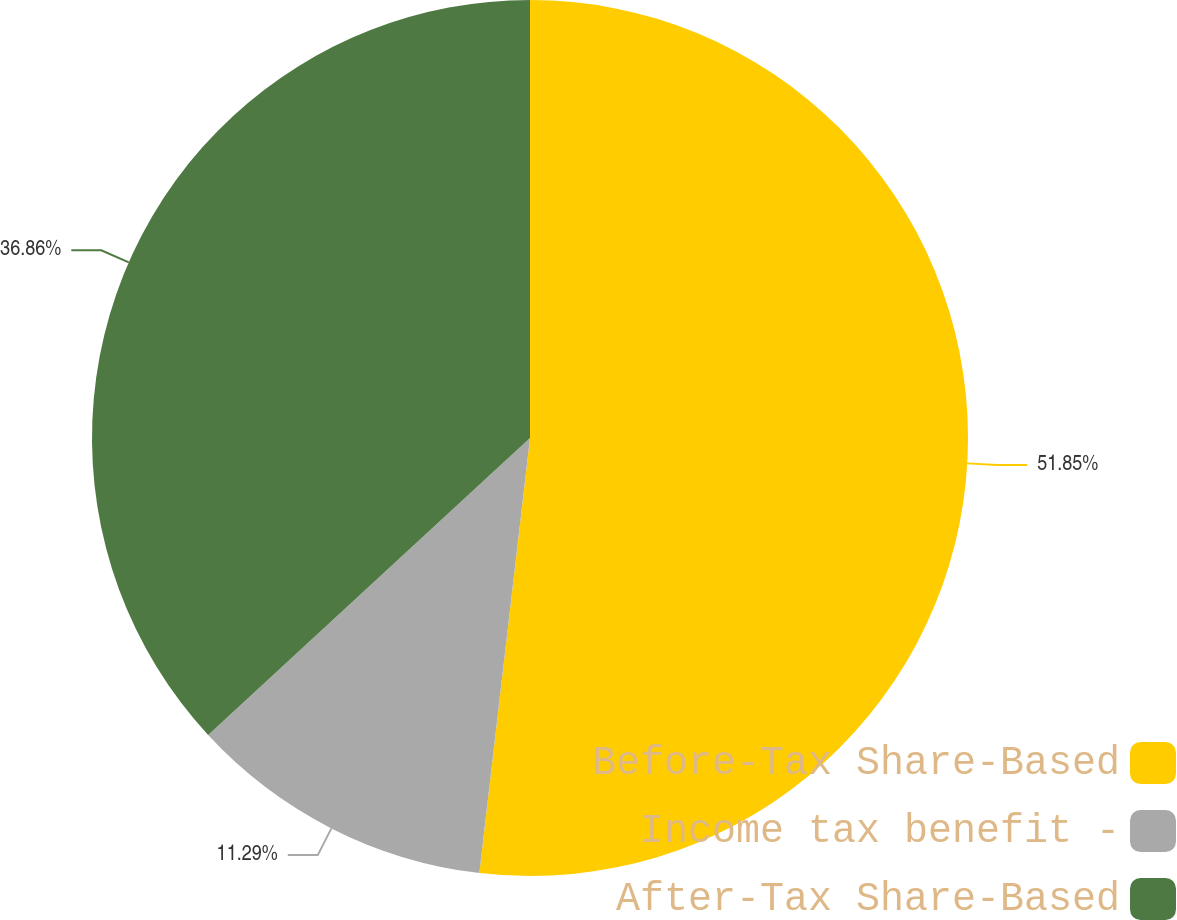Convert chart to OTSL. <chart><loc_0><loc_0><loc_500><loc_500><pie_chart><fcel>Before-Tax Share-Based<fcel>Income tax benefit -<fcel>After-Tax Share-Based<nl><fcel>51.84%<fcel>11.29%<fcel>36.86%<nl></chart> 